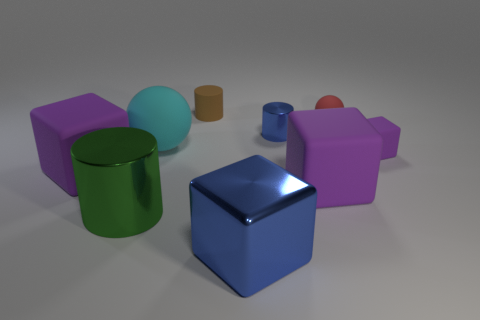Is the small metal cylinder the same color as the big metallic block?
Ensure brevity in your answer.  Yes. What is the material of the big cylinder?
Your response must be concise. Metal. What is the size of the ball that is in front of the small rubber sphere?
Provide a short and direct response. Large. What number of big things are the same shape as the tiny blue thing?
Offer a terse response. 1. What is the shape of the tiny purple object that is the same material as the large cyan thing?
Your response must be concise. Cube. How many cyan objects are either small rubber balls or tiny matte blocks?
Offer a very short reply. 0. Are there any tiny brown rubber things to the right of the brown matte thing?
Provide a short and direct response. No. There is a large purple rubber thing that is on the right side of the tiny brown rubber thing; does it have the same shape as the large purple rubber thing left of the green thing?
Provide a short and direct response. Yes. What is the material of the blue object that is the same shape as the green shiny object?
Give a very brief answer. Metal. What number of cylinders are either matte things or metal objects?
Offer a terse response. 3. 